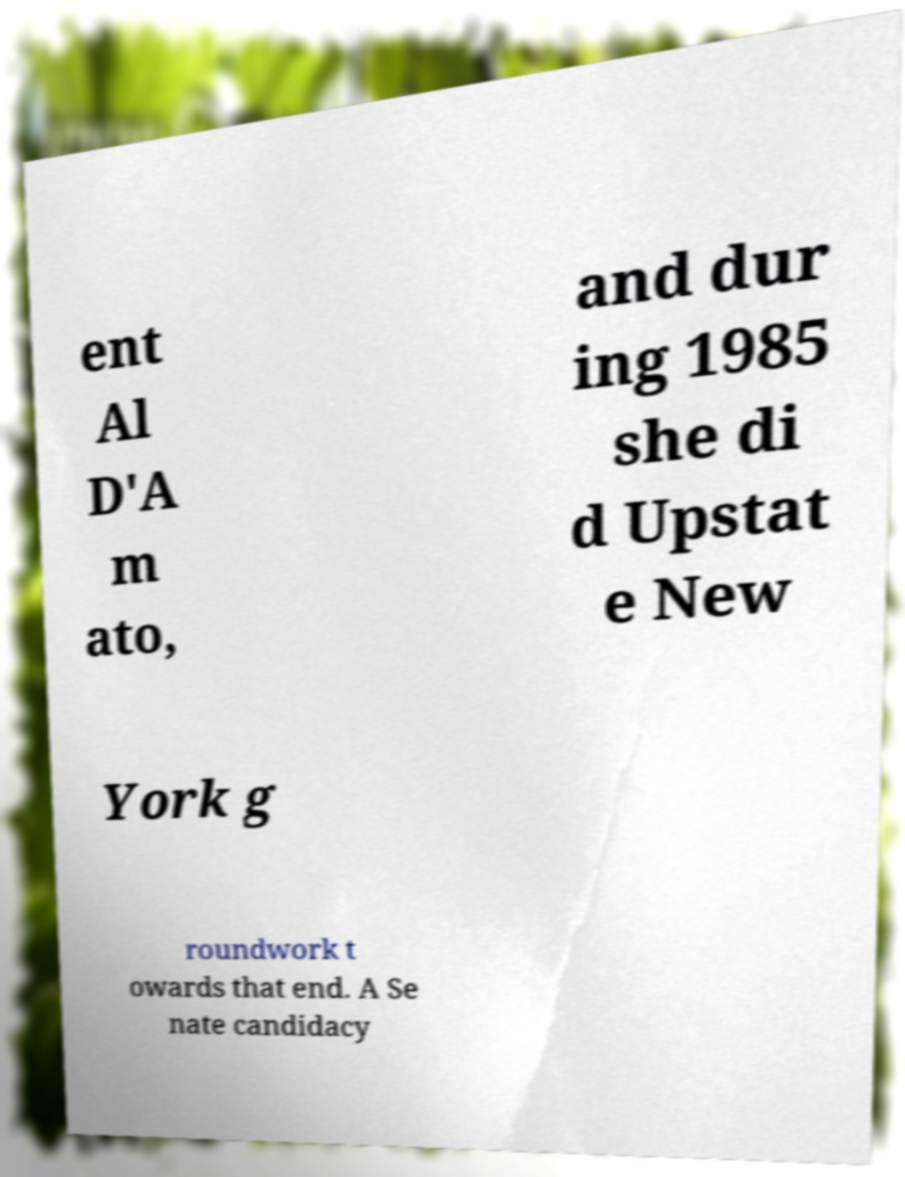Please read and relay the text visible in this image. What does it say? ent Al D'A m ato, and dur ing 1985 she di d Upstat e New York g roundwork t owards that end. A Se nate candidacy 